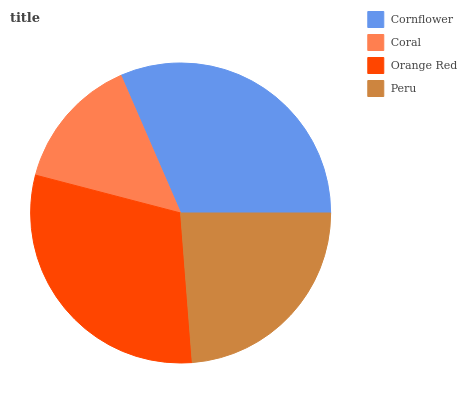Is Coral the minimum?
Answer yes or no. Yes. Is Cornflower the maximum?
Answer yes or no. Yes. Is Orange Red the minimum?
Answer yes or no. No. Is Orange Red the maximum?
Answer yes or no. No. Is Orange Red greater than Coral?
Answer yes or no. Yes. Is Coral less than Orange Red?
Answer yes or no. Yes. Is Coral greater than Orange Red?
Answer yes or no. No. Is Orange Red less than Coral?
Answer yes or no. No. Is Orange Red the high median?
Answer yes or no. Yes. Is Peru the low median?
Answer yes or no. Yes. Is Coral the high median?
Answer yes or no. No. Is Cornflower the low median?
Answer yes or no. No. 